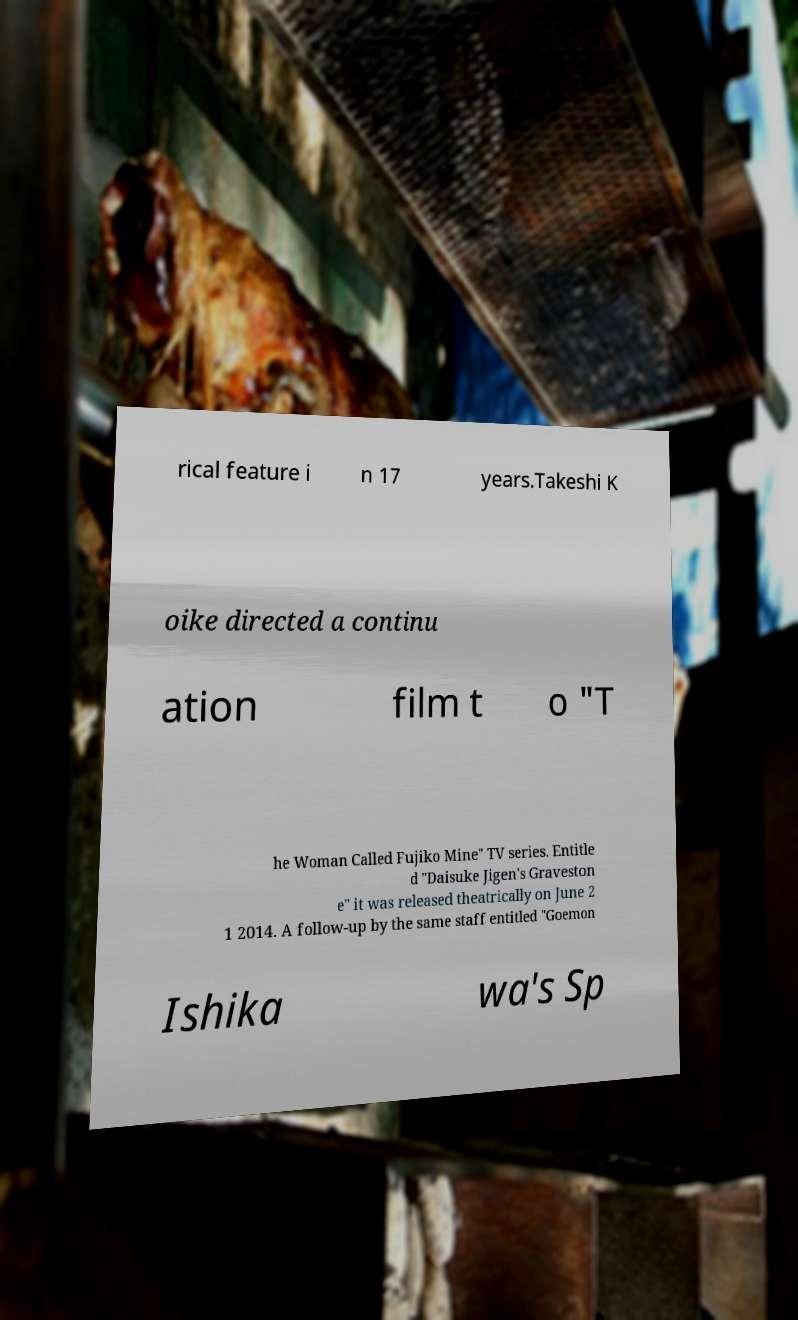Could you assist in decoding the text presented in this image and type it out clearly? rical feature i n 17 years.Takeshi K oike directed a continu ation film t o "T he Woman Called Fujiko Mine" TV series. Entitle d "Daisuke Jigen's Graveston e" it was released theatrically on June 2 1 2014. A follow-up by the same staff entitled "Goemon Ishika wa's Sp 